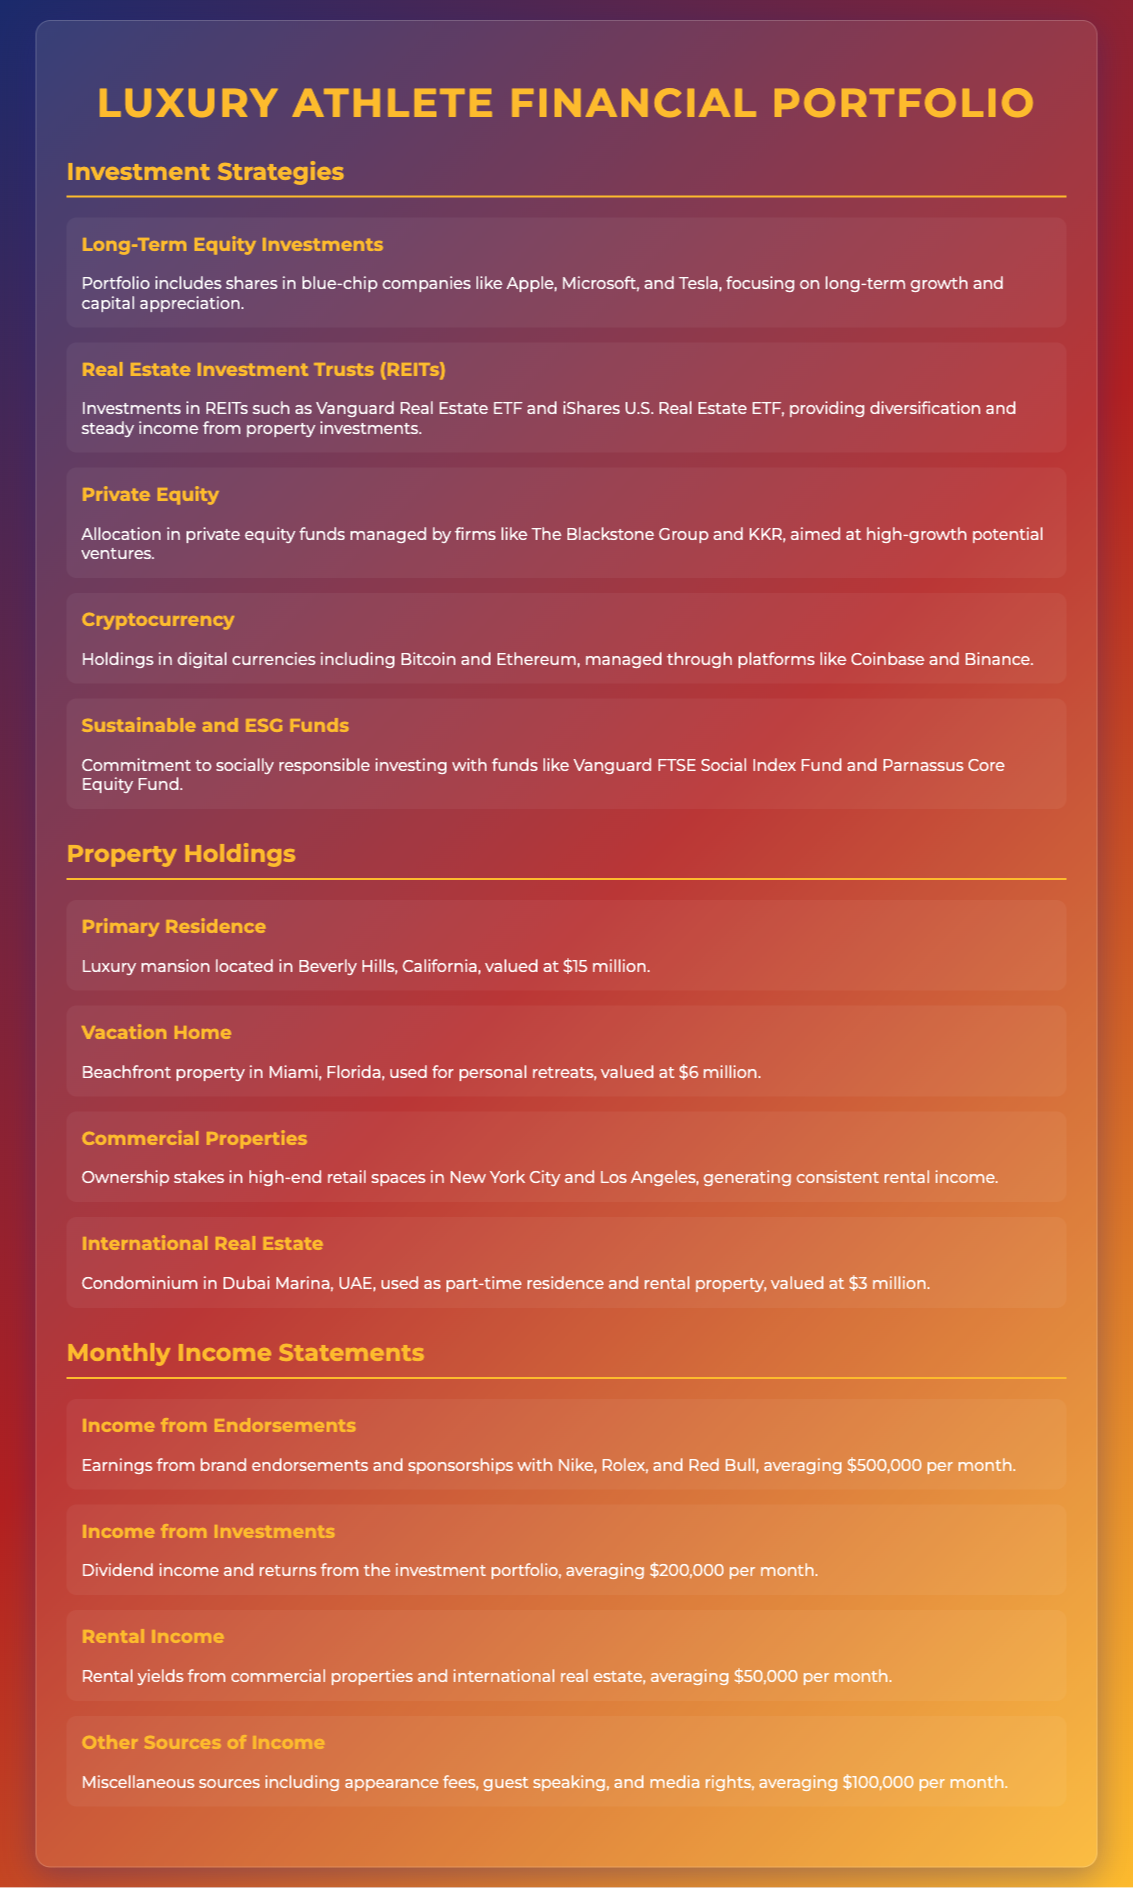What are the long-term equity investments? The document lists shares in blue-chip companies like Apple, Microsoft, and Tesla as long-term equity investments.
Answer: Apple, Microsoft, Tesla Which REITs are included in the investment portfolio? The document mentions Vanguard Real Estate ETF and iShares U.S. Real Estate ETF as part of the REIT investments.
Answer: Vanguard Real Estate ETF, iShares U.S. Real Estate ETF What is the value of the primary residence? The primary residence is a luxury mansion located in Beverly Hills, California, valued at $15 million.
Answer: $15 million How much does income from endorsements average per month? The document states that earnings from endorsements and sponsorships average $500,000 per month.
Answer: $500,000 What is the total monthly income from investments and rentals? The total is calculated as income from investments ($200,000) plus rental income ($50,000), totaling $250,000.
Answer: $250,000 Which company manages private equity funds? The document lists The Blackstone Group as one of the firms managing private equity funds.
Answer: The Blackstone Group What is the value of the beachfront property in Miami? The beachfront property in Miami is valued at $6 million.
Answer: $6 million What is the average monthly income from other sources? The document states that other sources of income average $100,000 per month.
Answer: $100,000 What type of real estate is held in Dubai? The document states that a condominium in Dubai Marina is part of the property holdings.
Answer: Condominium in Dubai Marina 